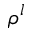Convert formula to latex. <formula><loc_0><loc_0><loc_500><loc_500>\rho ^ { l }</formula> 